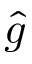<formula> <loc_0><loc_0><loc_500><loc_500>\hat { g }</formula> 